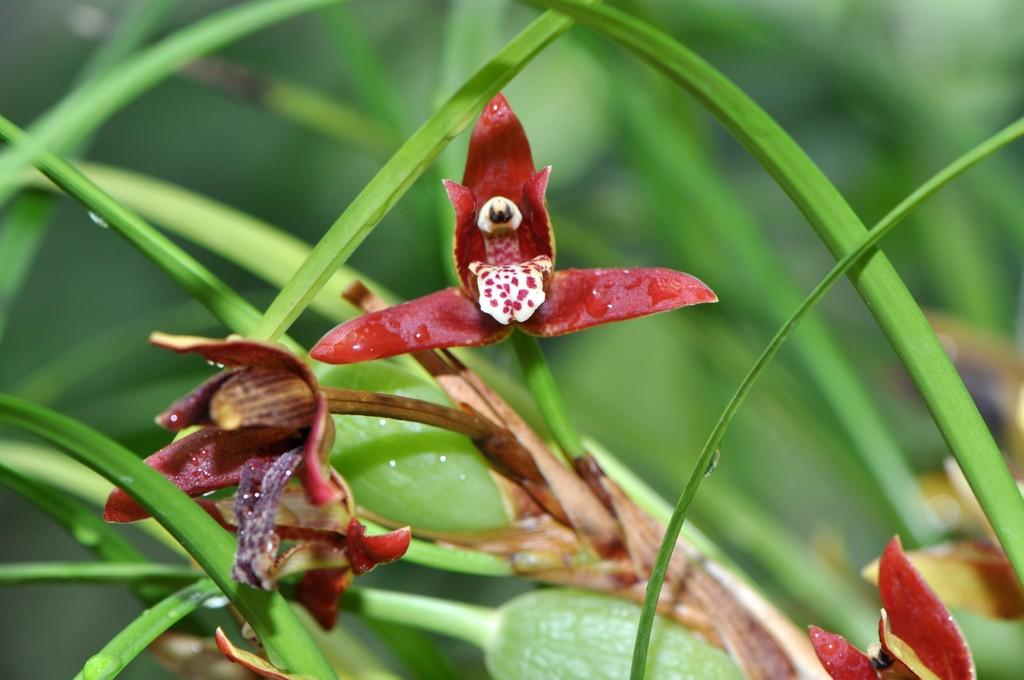What type of plants can be seen in the image? There are flowers in the image. Can you describe the stage of growth for some of the plants in the image? Yes, there are buds in the image, which are flowers in the early stages of development. Is the image set in a dangerous area with quicksand? There is no indication of quicksand or any danger in the image; it features flowers and buds. What time of day is depicted in the image? The time of day is not mentioned or depicted in the image, so it cannot be determined from the image alone. 